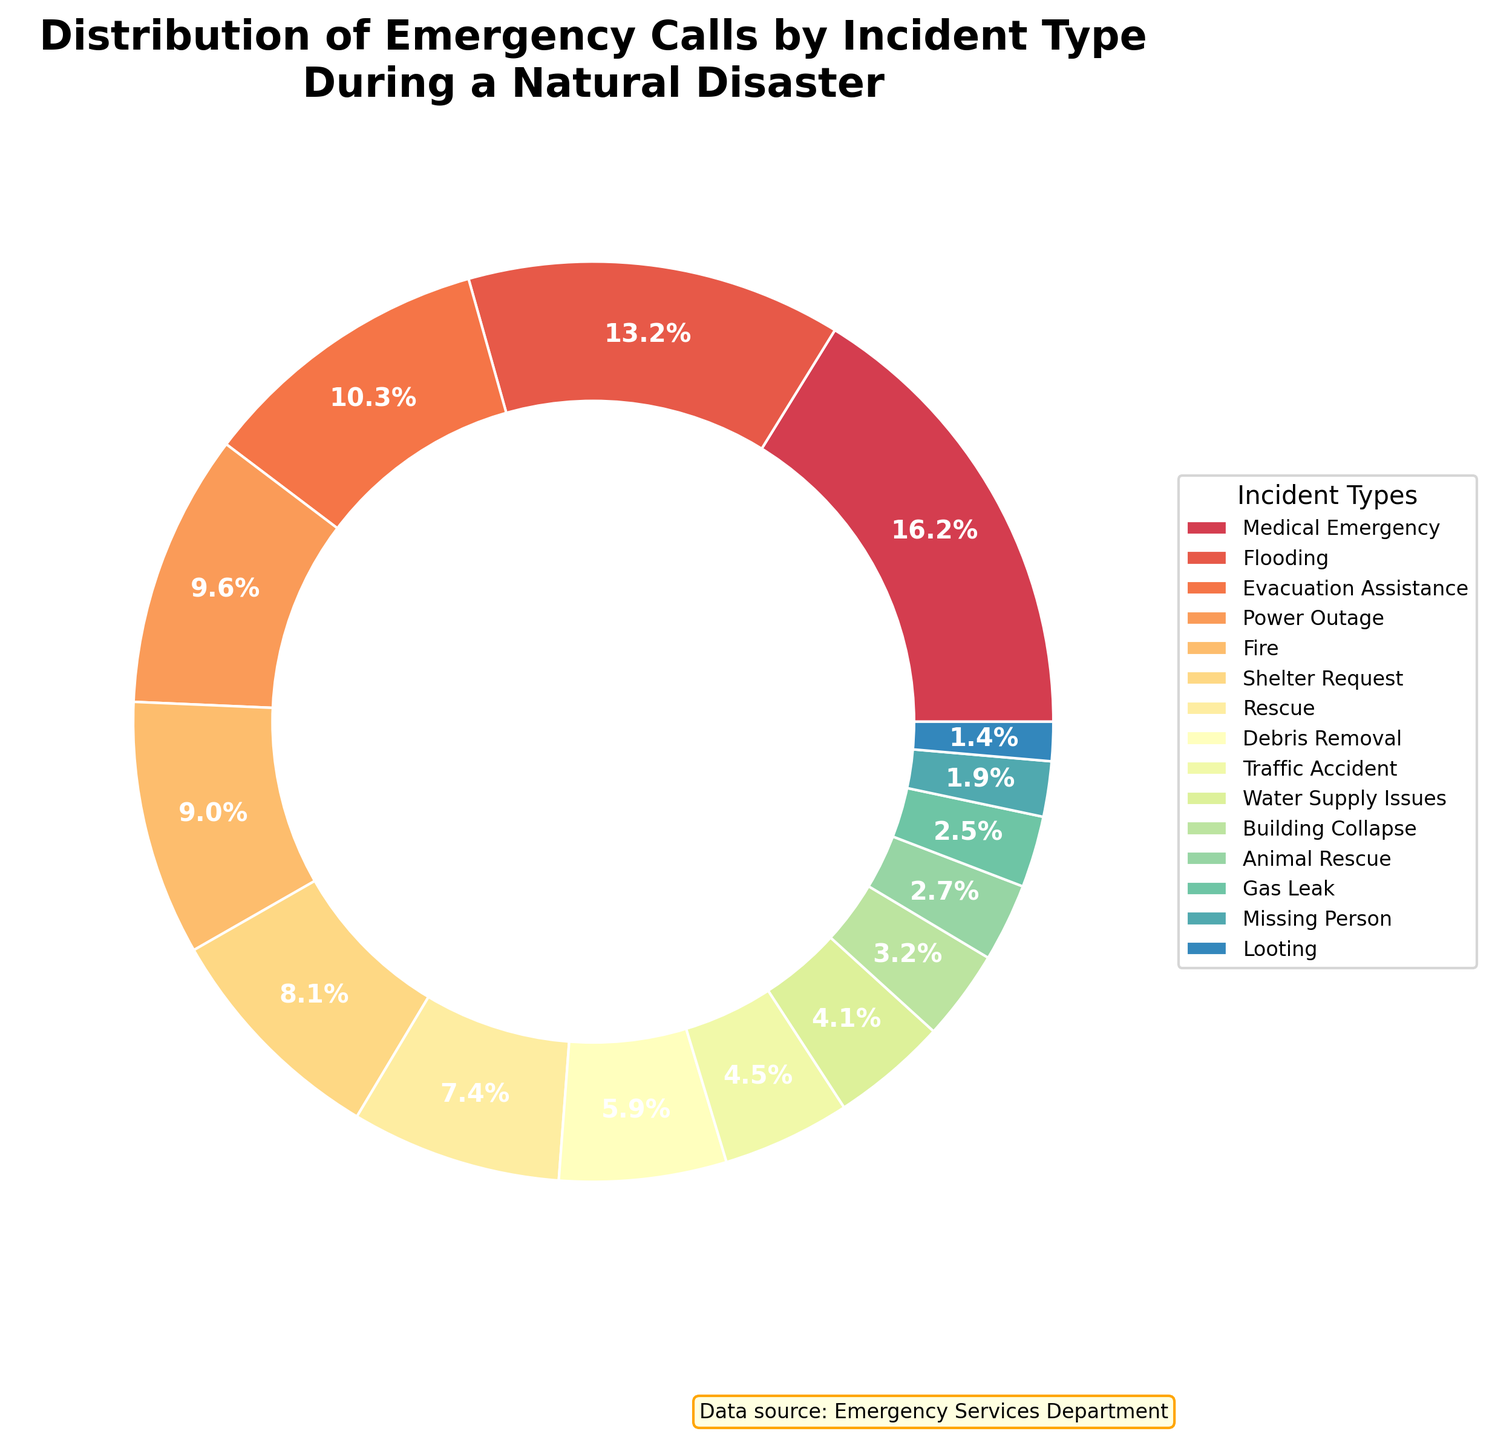Which incident type received the highest number of emergency calls? The incident type with the highest percentage on the pie chart indicates the highest number of calls.
Answer: Medical Emergency How many incident types had a call percentage above 10%? Check the legend for the percent values of each incident type. There are three incident types above 10%: Medical Emergency, Flooding, and Evacuation Assistance.
Answer: 3 What is the combined call percentage for Fire and Power Outage incidents? Locate the percentages for Fire and Power Outage on the pie chart and sum them up: Fire (approx. 10.3%) + Power Outage (approx. 11%)
Answer: 21.3% Which incident type had the lowest percentage of calls? The smallest segment of the pie chart represents the lowest percentage.
Answer: Looting Compare the number of calls for Building Collapse and Debris Removal. Which was higher? Locate the segments for Building Collapse and Debris Removal. Debris Removal has a larger segment than Building Collapse.
Answer: Debris Removal How much greater is the call percentage for Medical Emergency compared to Rescue? Find the percentages for Medical Emergency and Rescue and subtract the smaller from the larger: (approx. 19%) - (approx. 8.6%)
Answer: 10.4% What is the percentage difference between Shelter Request and Traffic Accident calls? Identify the percentages for Shelter Request and Traffic Accident and subtract the smaller from the larger: (approx. 9.6%) - (approx. 5.3%)
Answer: 4.3% How many incident types have a percentage between 5% and 10%? Check the legend for segments with percentages between 5% and 10%. Building Collapse, Debris Removal, Gas Leak, and Water Supply Issues fall in this range.
Answer: 4 Describe the proportion of Animal Rescue calls compared to Medical Emergency calls. Compare the segments of Animal Rescue and Medical Emergency. Medical Emergency has a much larger segment compared to Animal Rescue.
Answer: Much smaller If the total number of calls doubles, what will be the new call count for Evacuation Assistance? Double the current number of calls for Evacuation Assistance: 218 calls * 2
Answer: 436 